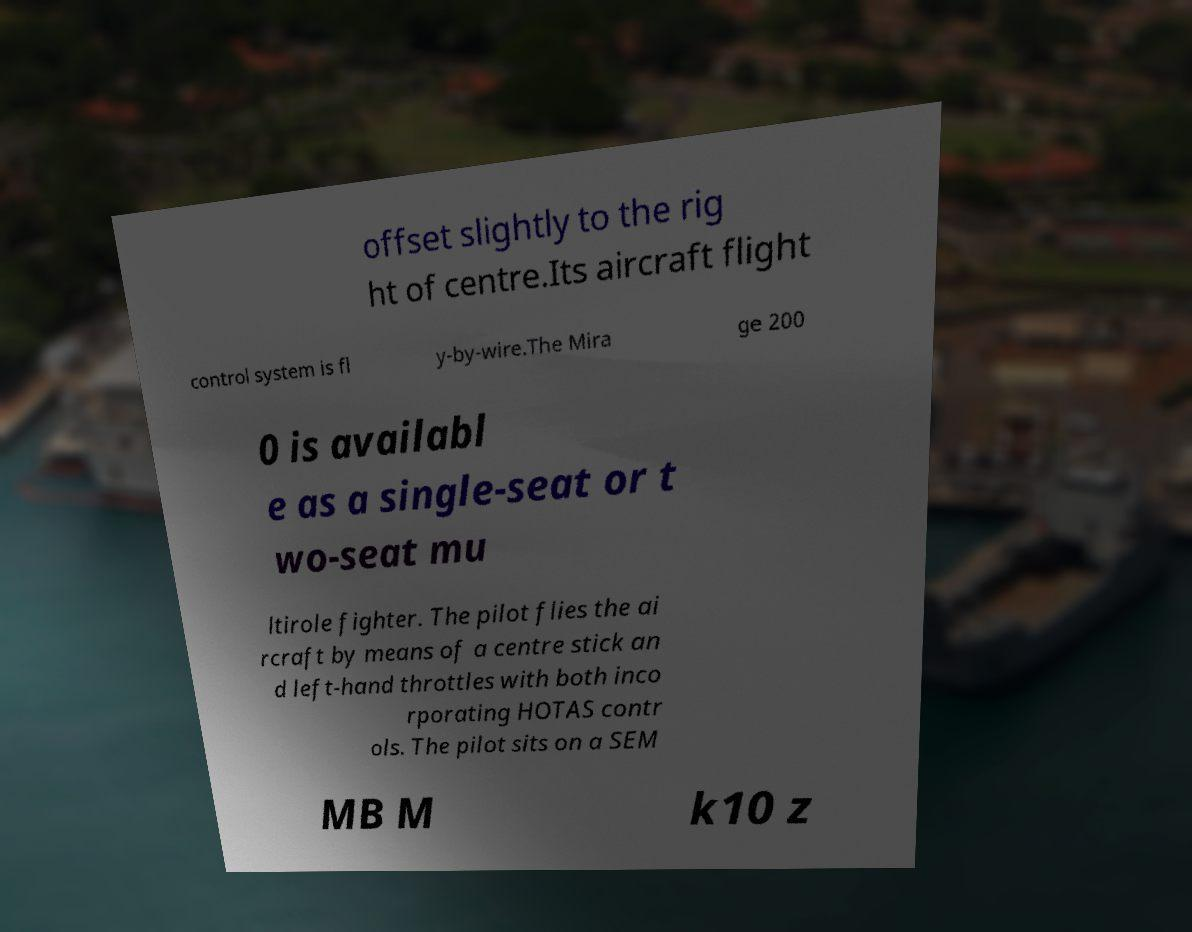Please read and relay the text visible in this image. What does it say? offset slightly to the rig ht of centre.Its aircraft flight control system is fl y-by-wire.The Mira ge 200 0 is availabl e as a single-seat or t wo-seat mu ltirole fighter. The pilot flies the ai rcraft by means of a centre stick an d left-hand throttles with both inco rporating HOTAS contr ols. The pilot sits on a SEM MB M k10 z 